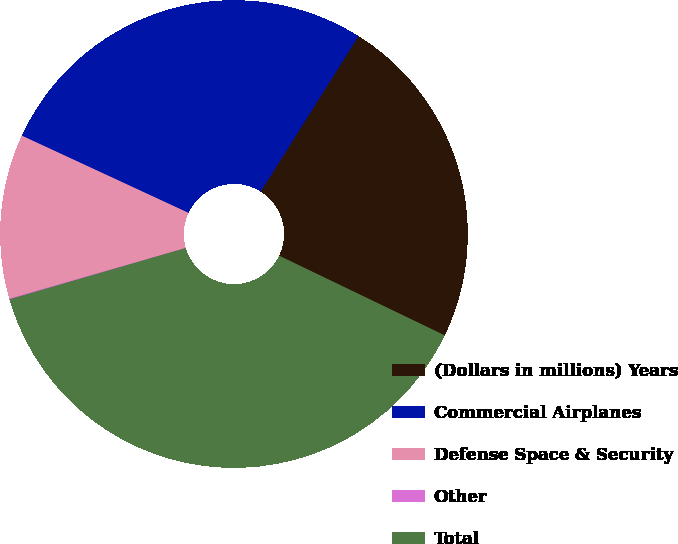Convert chart. <chart><loc_0><loc_0><loc_500><loc_500><pie_chart><fcel>(Dollars in millions) Years<fcel>Commercial Airplanes<fcel>Defense Space & Security<fcel>Other<fcel>Total<nl><fcel>23.2%<fcel>27.03%<fcel>11.35%<fcel>0.06%<fcel>38.36%<nl></chart> 